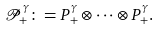<formula> <loc_0><loc_0><loc_500><loc_500>\mathcal { P _ { + } ^ { \gamma } } \colon = P _ { + } ^ { \gamma } \otimes \cdots \otimes P _ { + } ^ { \gamma } .</formula> 